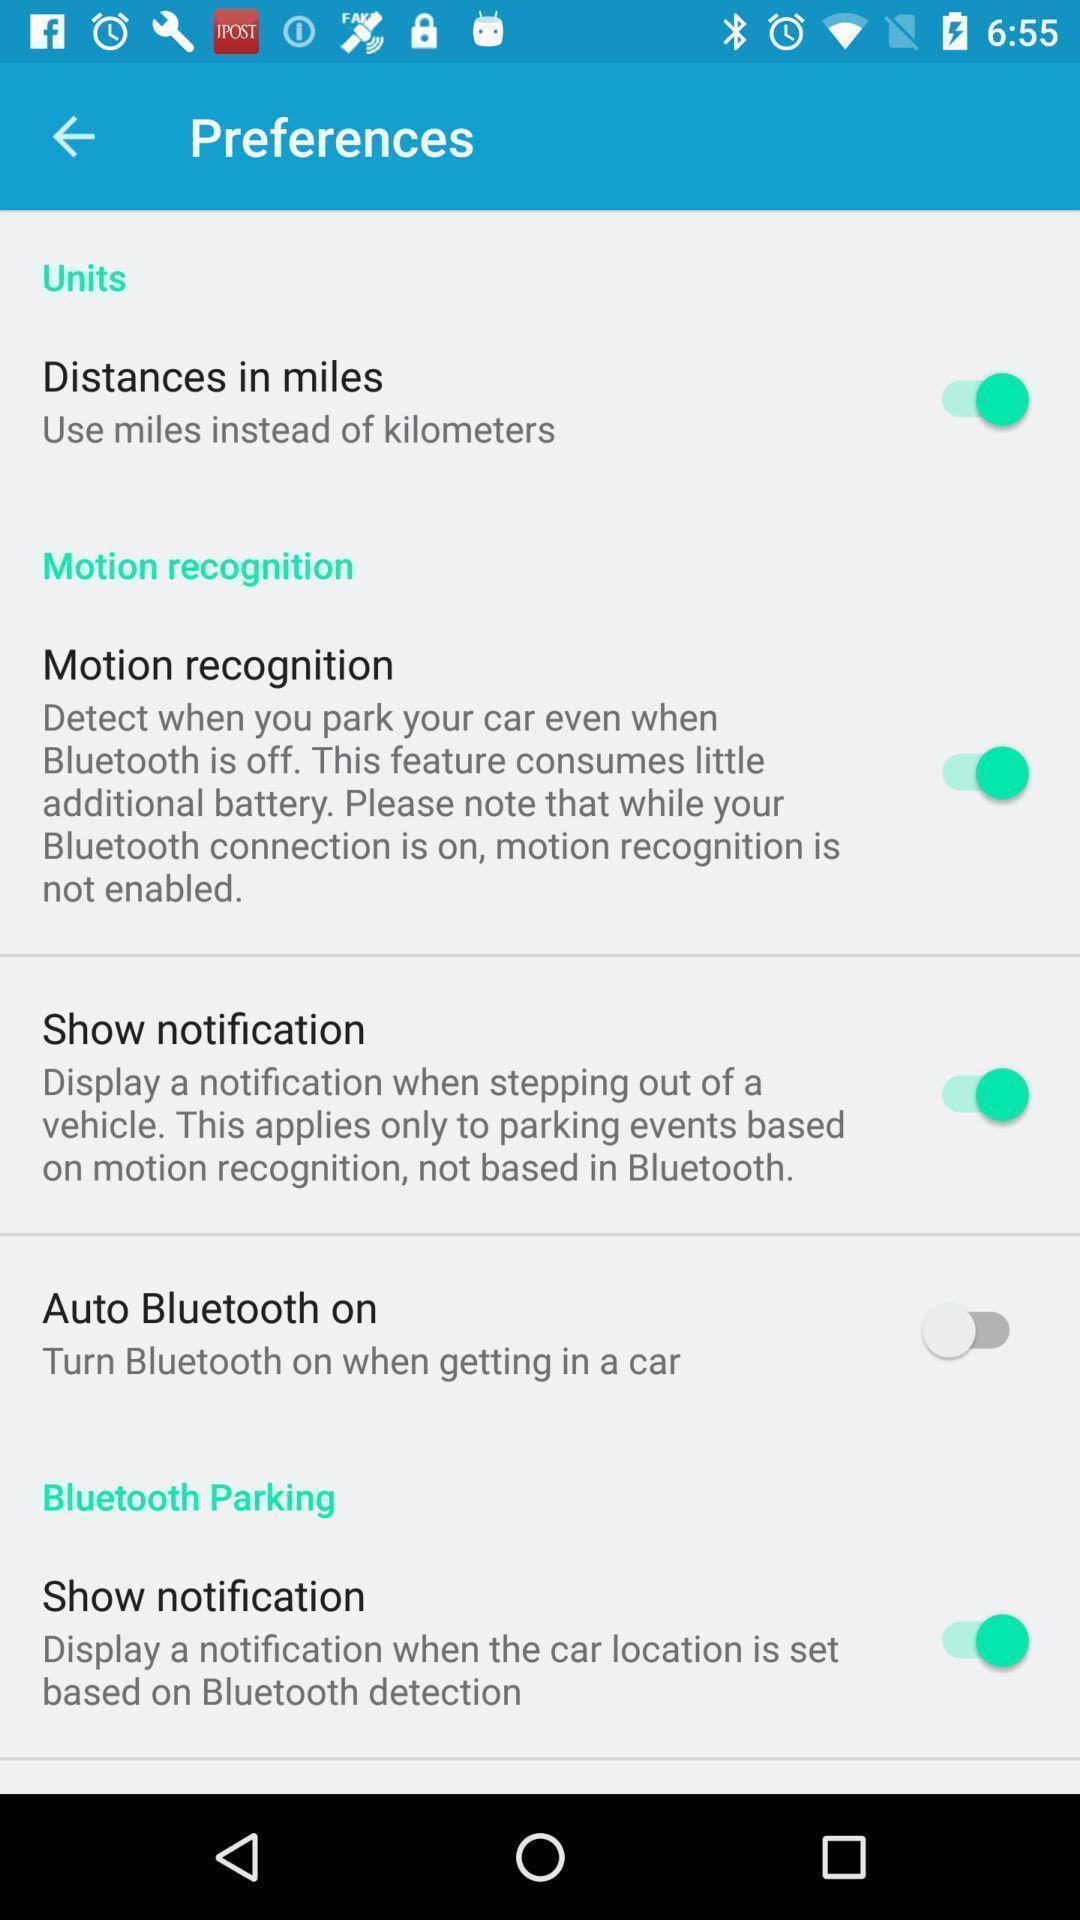What details can you identify in this image? Settings page with number of options to enable or disable. 